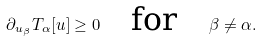<formula> <loc_0><loc_0><loc_500><loc_500>\partial _ { u _ { \beta } } T _ { \alpha } [ u ] \geq 0 \quad \text {for} \quad \beta \neq \alpha .</formula> 